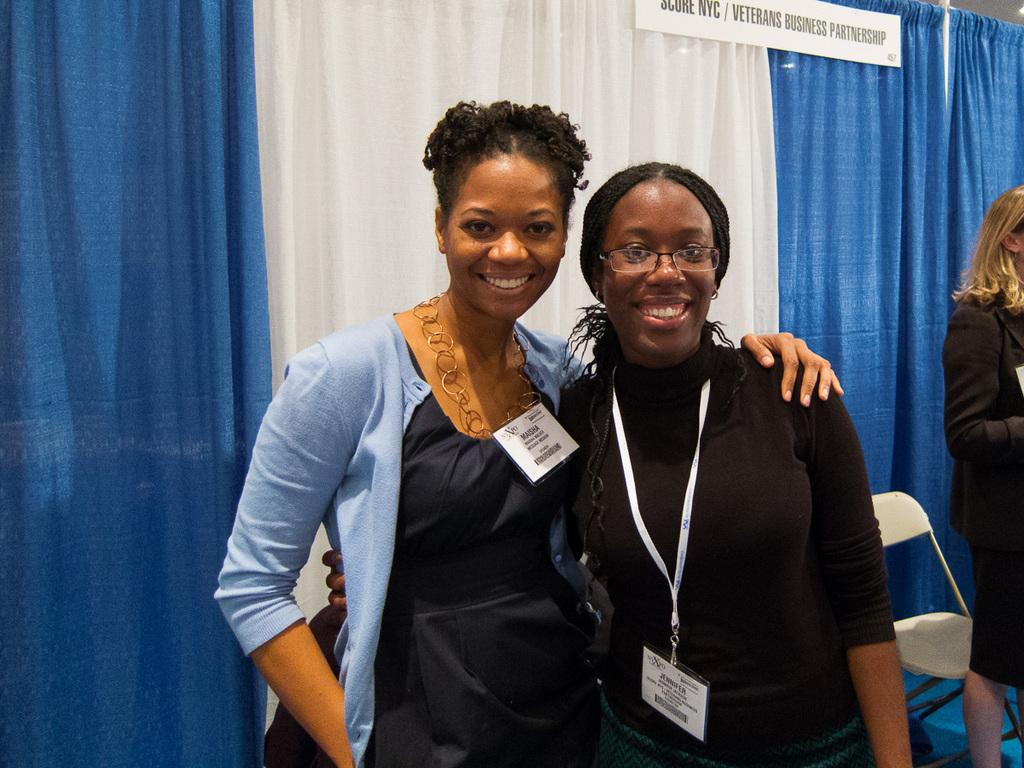What are the women in the image doing? The women in the image are standing and smiling. Can you describe the background of the image? In the background, there is a woman standing on the floor, a chair, a name board, and a curtain. How many women are visible in the image? There are multiple women standing and smiling in the image. What might the name board be used for? The name board in the background could be used for identification or labeling purposes. What type of cheese can be seen on the chair in the image? There is no cheese present in the image; it features women standing and smiling, along with various background elements. 